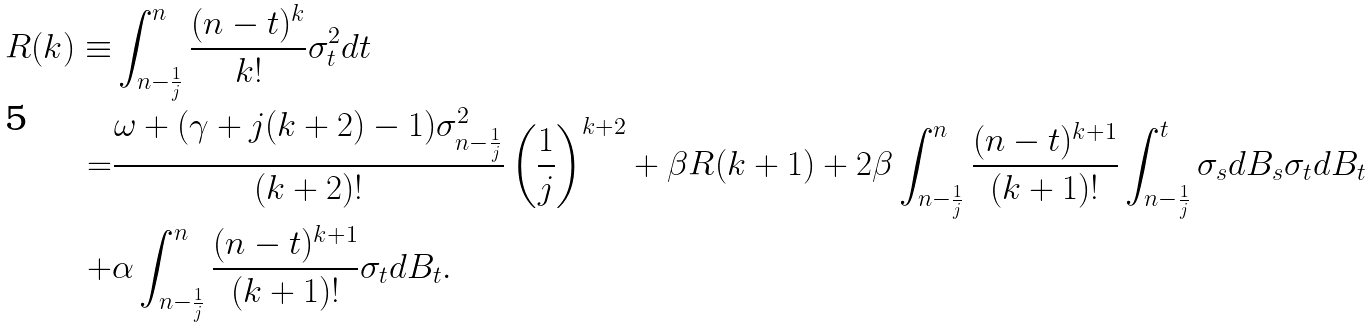<formula> <loc_0><loc_0><loc_500><loc_500>R ( k ) \equiv & \int _ { n - \frac { 1 } { j } } ^ { n } \frac { ( n - t ) ^ { k } } { k ! } \sigma _ { t } ^ { 2 } d t \\ = & \frac { \omega + ( \gamma + j ( k + 2 ) - 1 ) \sigma _ { n - \frac { 1 } { j } } ^ { 2 } } { ( k + 2 ) ! } \left ( \frac { 1 } { j } \right ) ^ { k + 2 } + \beta R ( k + 1 ) + 2 \beta \int _ { n - \frac { 1 } { j } } ^ { n } \frac { ( n - t ) ^ { k + 1 } } { ( k + 1 ) ! } \int _ { n - \frac { 1 } { j } } ^ { t } \sigma _ { s } d B _ { s } \sigma _ { t } d B _ { t } \\ + & \alpha \int _ { n - \frac { 1 } { j } } ^ { n } \frac { ( n - t ) ^ { k + 1 } } { ( k + 1 ) ! } \sigma _ { t } d B _ { t } .</formula> 